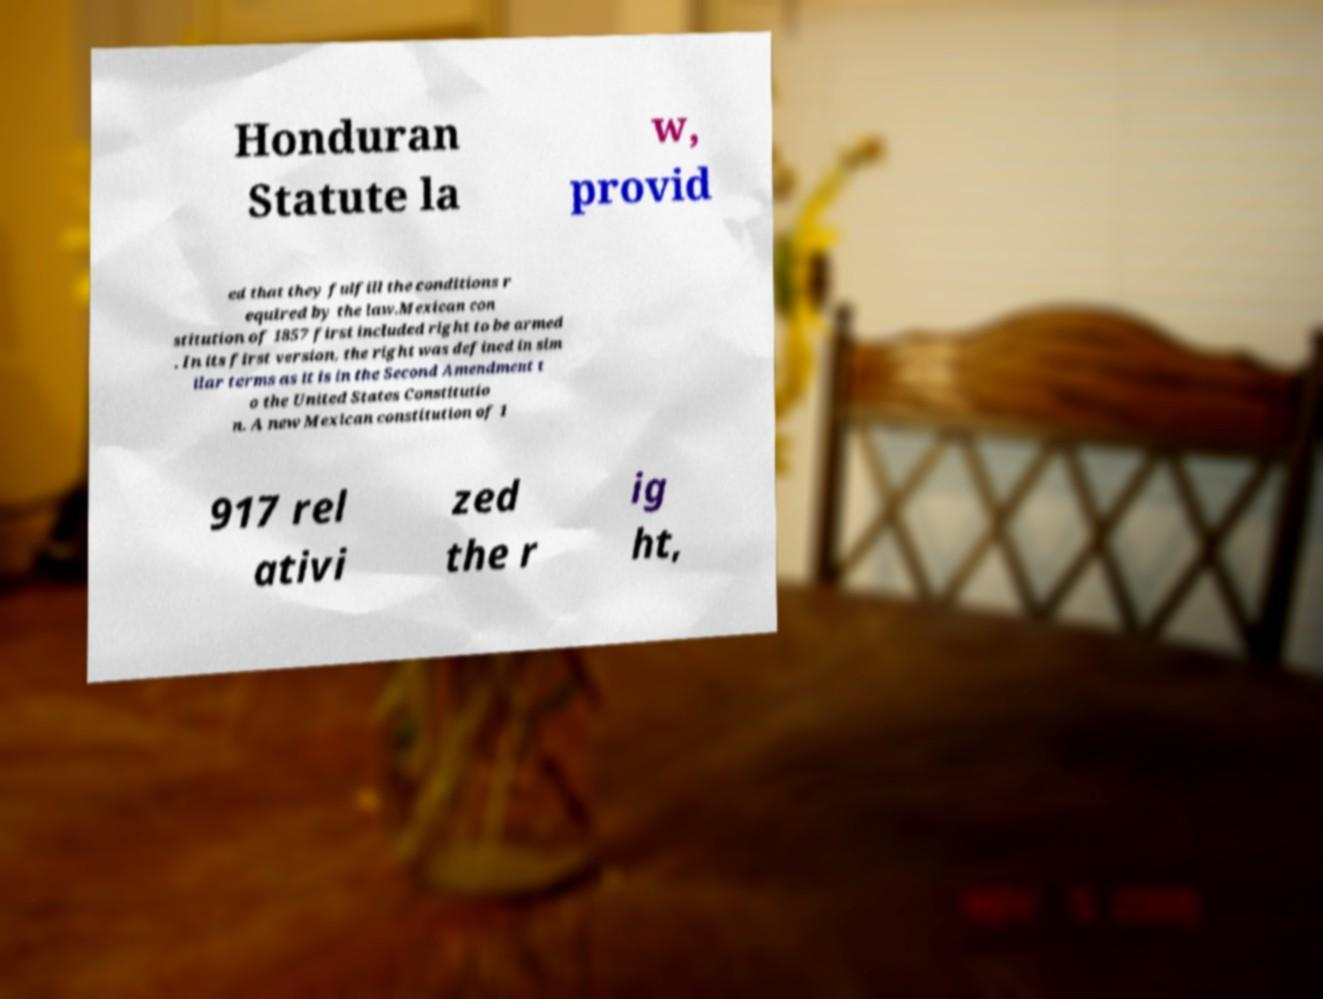Can you accurately transcribe the text from the provided image for me? Honduran Statute la w, provid ed that they fulfill the conditions r equired by the law.Mexican con stitution of 1857 first included right to be armed . In its first version, the right was defined in sim ilar terms as it is in the Second Amendment t o the United States Constitutio n. A new Mexican constitution of 1 917 rel ativi zed the r ig ht, 